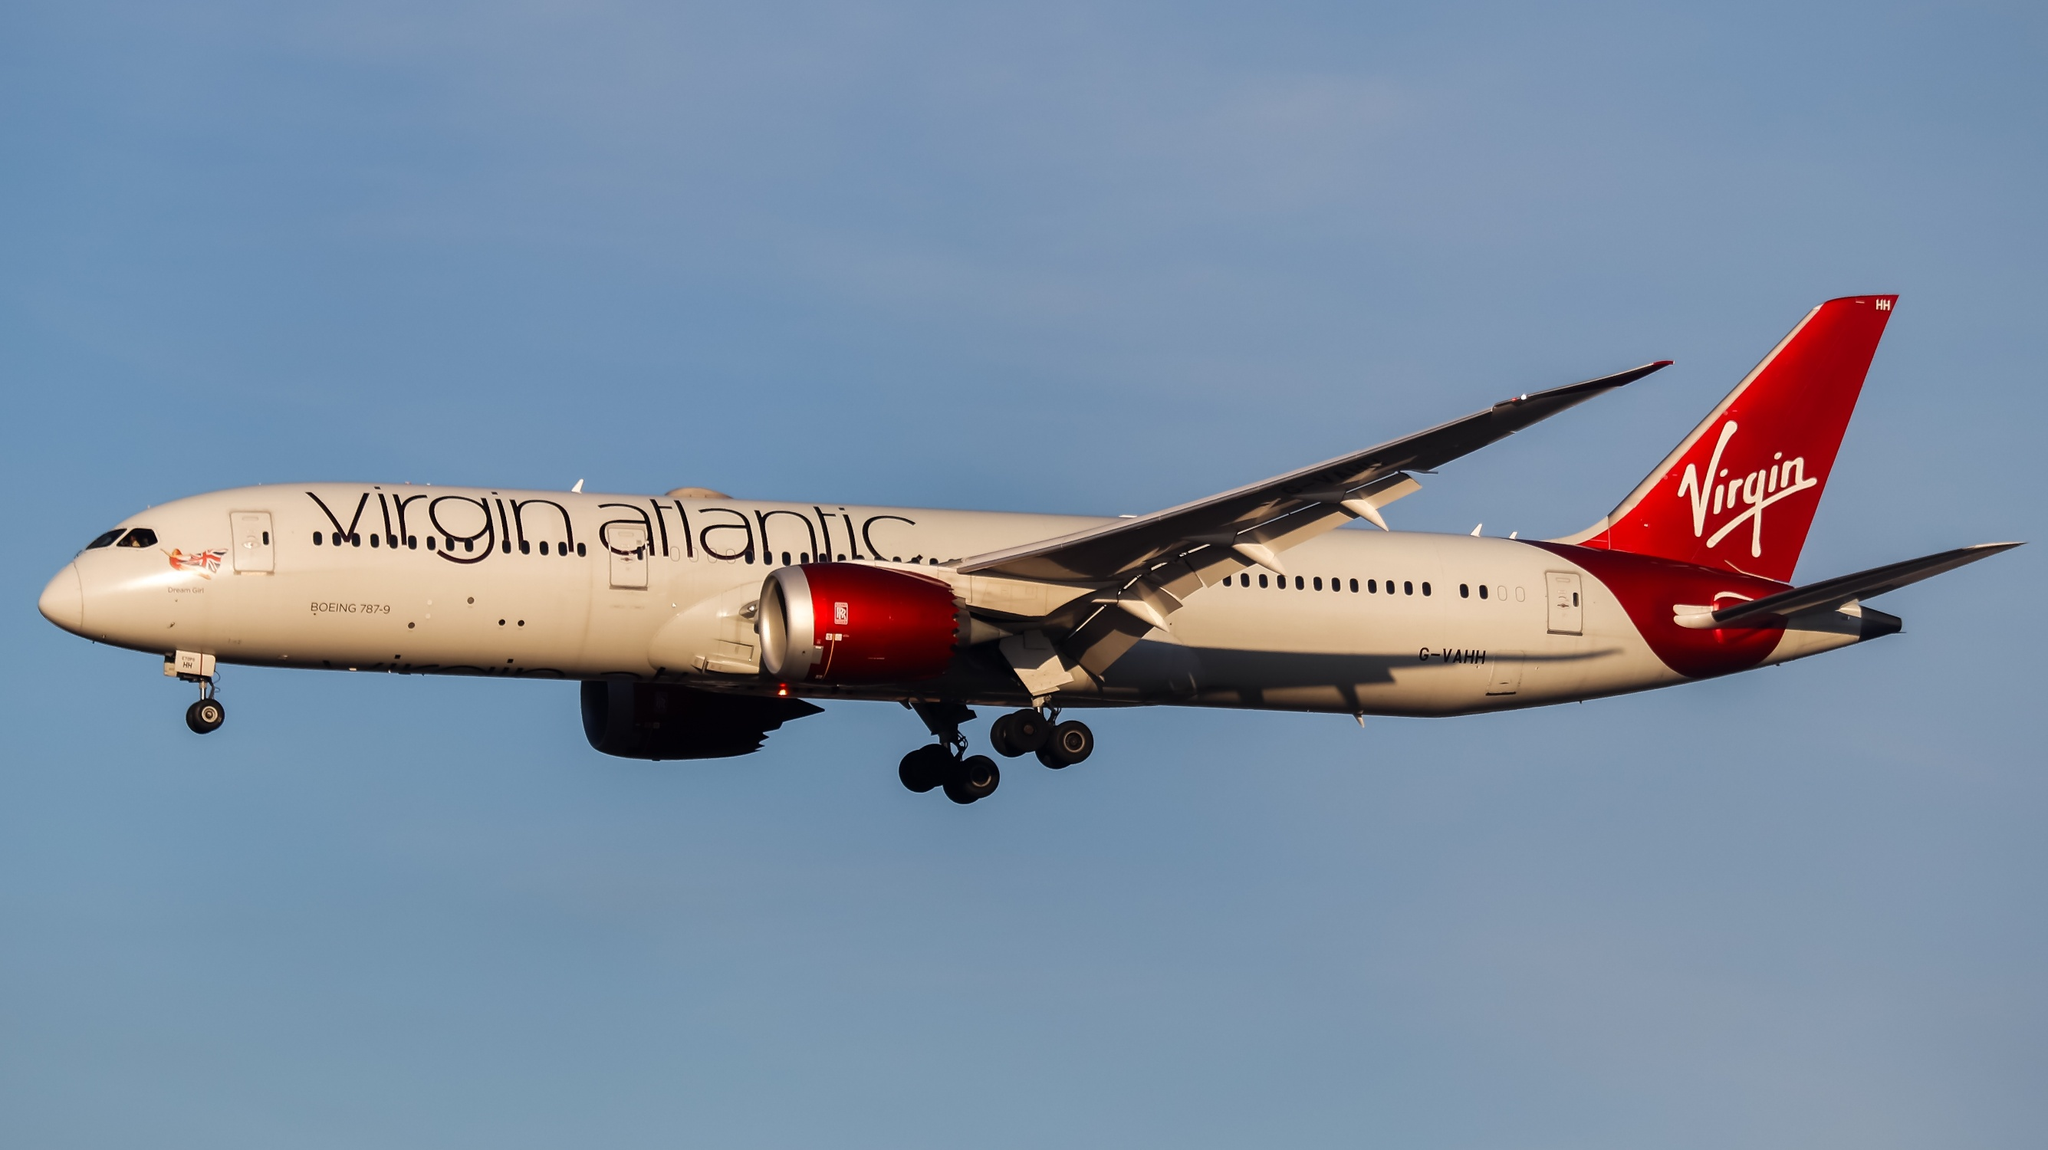What can you tell me about the history of this airplane model? The Boeing 787-9 Dreamliner, like the one depicted in this image, represents one of the most advanced and cost-efficient models in commercial aviation. Introduced in 2013, the 787-9 is part of the Boeing 787 Dreamliner family, known for its fuel efficiency, advanced aerodynamics, and passenger comfort. It features innovative technologies such as composite materials, enhanced environmental performance, and quieter engines. The Dreamliner series was developed to meet the growing demand for efficient long-haul flights and has since become a favorite among airlines for its operational efficiency and customer satisfaction. Virgin Atlantic was one of the early adopters of the 787-9, utilizing the aircraft to offer premier service on both transatlantic and international routes. 